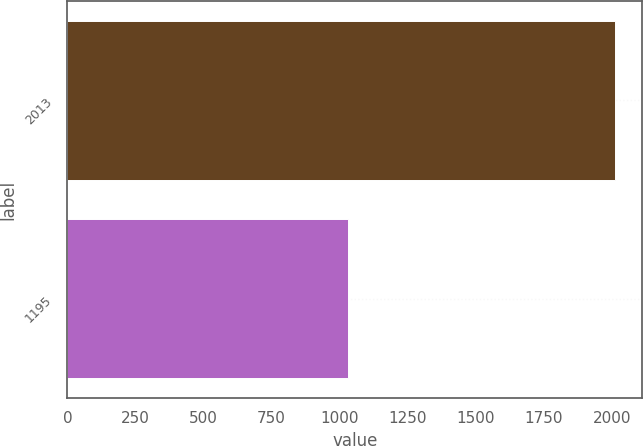Convert chart. <chart><loc_0><loc_0><loc_500><loc_500><bar_chart><fcel>2013<fcel>1195<nl><fcel>2011<fcel>1031<nl></chart> 